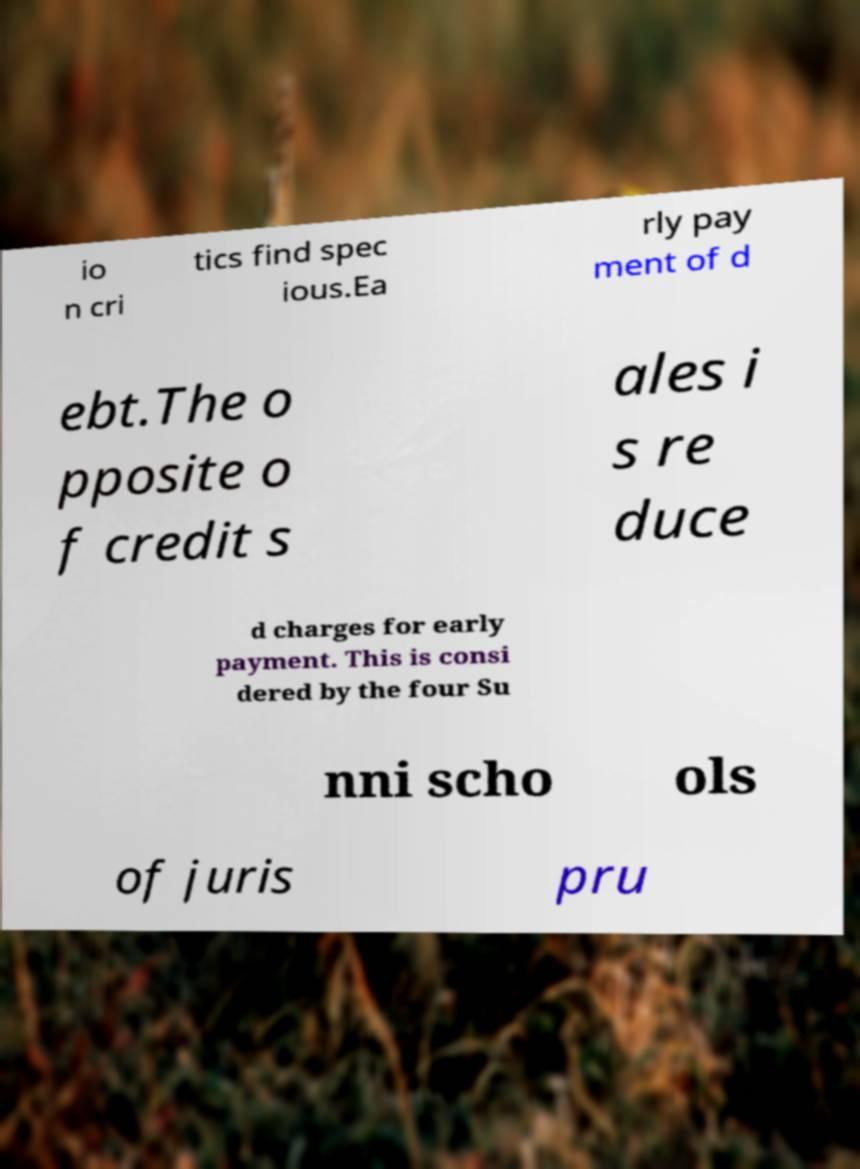There's text embedded in this image that I need extracted. Can you transcribe it verbatim? io n cri tics find spec ious.Ea rly pay ment of d ebt.The o pposite o f credit s ales i s re duce d charges for early payment. This is consi dered by the four Su nni scho ols of juris pru 